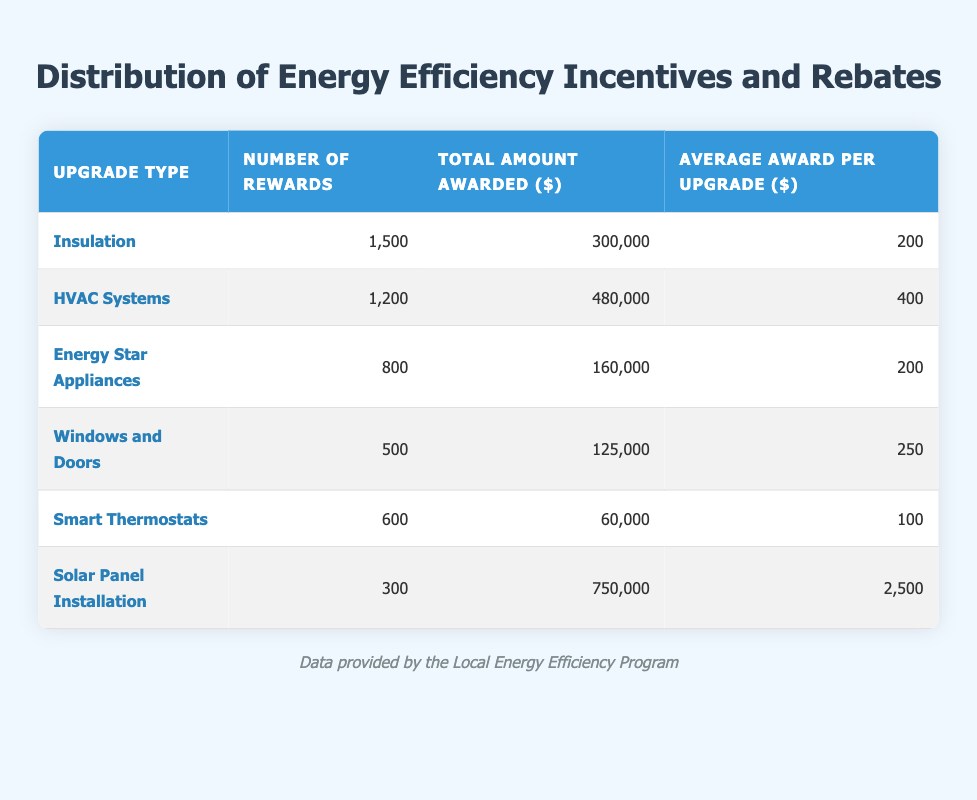What is the total amount awarded for HVAC systems? The table states the total amount awarded for HVAC systems is given in the respective column. Specifically, it is listed as $480,000.
Answer: 480000 How many rewards were given for Smart Thermostats? The number of rewards for Smart Thermostats can be found directly in the table under the "Number of Rewards" column, where it is shown as 600.
Answer: 600 What is the average award amount for Solar Panel Installation? The average award per upgrade for Solar Panel Installation is explicitly mentioned in the table, which states it is $2,500.
Answer: 2500 Which upgrade type has the highest average award per upgrade? To find the upgrade type with the highest average award, we compare the values in the "Average Award per Upgrade" column. Solar Panel Installation has the highest value at $2,500.
Answer: Solar Panel Installation How many total rewards were given for insulation and Windows and Doors combined? We calculate the total rewards for both Insulation and Windows and Doors by summing their respective numbers. For Insulation, it is 1500, and for Windows and Doors, it is 500. Therefore, the total is 1500 + 500 = 2000.
Answer: 2000 Is the total amount awarded for Energy Star Appliances more than that of Smart Thermostats? We can check the total amounts awarded: Energy Star Appliances is $160,000 and Smart Thermostats is $60,000. Since $160,000 is greater than $60,000, the statement is true.
Answer: Yes What is the total amount awarded across all upgrade types? To find the total amount awarded for all types, we add the total amounts from each row in the "Total Amount Awarded" column. The sum is $300,000 + $480,000 + $160,000 + $125,000 + $60,000 + $750,000 = $1,875,000.
Answer: 1875000 Which upgrade type received fewer than 600 rewards? We review the "Number of Rewards" column for each upgrade type and identify those with fewer than 600 rewards. From the table, we find that Windows and Doors (500) and Solar Panel Installation (300) both received fewer than 600 rewards.
Answer: Windows and Doors, Solar Panel Installation What is the difference in the average awards between HVAC Systems and Smart Thermostats? To find the difference, we subtract the average award for Smart Thermostats ($100) from that of HVAC Systems ($400). Therefore, the difference is $400 - $100 = $300.
Answer: 300 